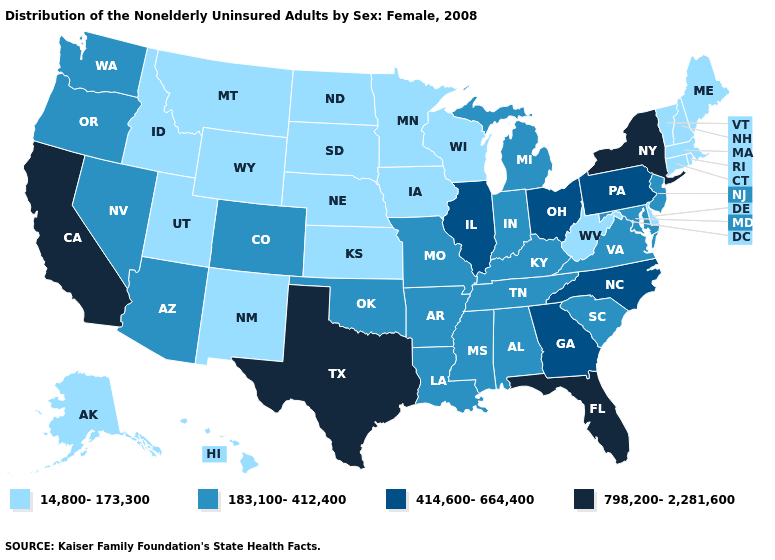Among the states that border Florida , which have the highest value?
Write a very short answer. Georgia. Does Ohio have the highest value in the USA?
Answer briefly. No. What is the lowest value in the USA?
Give a very brief answer. 14,800-173,300. Which states have the lowest value in the USA?
Keep it brief. Alaska, Connecticut, Delaware, Hawaii, Idaho, Iowa, Kansas, Maine, Massachusetts, Minnesota, Montana, Nebraska, New Hampshire, New Mexico, North Dakota, Rhode Island, South Dakota, Utah, Vermont, West Virginia, Wisconsin, Wyoming. Does New Hampshire have the same value as Vermont?
Quick response, please. Yes. What is the value of South Carolina?
Concise answer only. 183,100-412,400. Does the map have missing data?
Give a very brief answer. No. Is the legend a continuous bar?
Be succinct. No. Does Idaho have the lowest value in the USA?
Quick response, please. Yes. Name the states that have a value in the range 183,100-412,400?
Give a very brief answer. Alabama, Arizona, Arkansas, Colorado, Indiana, Kentucky, Louisiana, Maryland, Michigan, Mississippi, Missouri, Nevada, New Jersey, Oklahoma, Oregon, South Carolina, Tennessee, Virginia, Washington. What is the value of Mississippi?
Short answer required. 183,100-412,400. What is the lowest value in the Northeast?
Answer briefly. 14,800-173,300. Is the legend a continuous bar?
Write a very short answer. No. Among the states that border Florida , does Alabama have the lowest value?
Short answer required. Yes. Does Arkansas have the highest value in the USA?
Write a very short answer. No. 